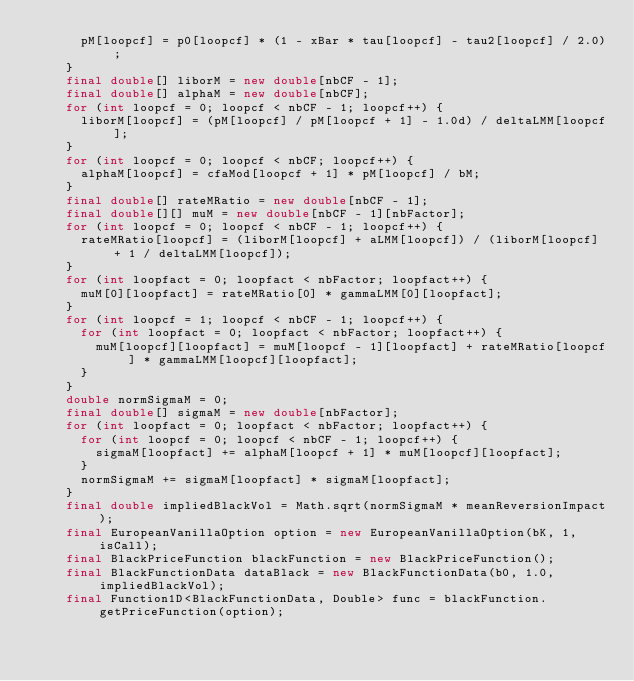<code> <loc_0><loc_0><loc_500><loc_500><_Java_>      pM[loopcf] = p0[loopcf] * (1 - xBar * tau[loopcf] - tau2[loopcf] / 2.0);
    }
    final double[] liborM = new double[nbCF - 1];
    final double[] alphaM = new double[nbCF];
    for (int loopcf = 0; loopcf < nbCF - 1; loopcf++) {
      liborM[loopcf] = (pM[loopcf] / pM[loopcf + 1] - 1.0d) / deltaLMM[loopcf];
    }
    for (int loopcf = 0; loopcf < nbCF; loopcf++) {
      alphaM[loopcf] = cfaMod[loopcf + 1] * pM[loopcf] / bM;
    }
    final double[] rateMRatio = new double[nbCF - 1];
    final double[][] muM = new double[nbCF - 1][nbFactor];
    for (int loopcf = 0; loopcf < nbCF - 1; loopcf++) {
      rateMRatio[loopcf] = (liborM[loopcf] + aLMM[loopcf]) / (liborM[loopcf] + 1 / deltaLMM[loopcf]);
    }
    for (int loopfact = 0; loopfact < nbFactor; loopfact++) {
      muM[0][loopfact] = rateMRatio[0] * gammaLMM[0][loopfact];
    }
    for (int loopcf = 1; loopcf < nbCF - 1; loopcf++) {
      for (int loopfact = 0; loopfact < nbFactor; loopfact++) {
        muM[loopcf][loopfact] = muM[loopcf - 1][loopfact] + rateMRatio[loopcf] * gammaLMM[loopcf][loopfact];
      }
    }
    double normSigmaM = 0;
    final double[] sigmaM = new double[nbFactor];
    for (int loopfact = 0; loopfact < nbFactor; loopfact++) {
      for (int loopcf = 0; loopcf < nbCF - 1; loopcf++) {
        sigmaM[loopfact] += alphaM[loopcf + 1] * muM[loopcf][loopfact];
      }
      normSigmaM += sigmaM[loopfact] * sigmaM[loopfact];
    }
    final double impliedBlackVol = Math.sqrt(normSigmaM * meanReversionImpact);
    final EuropeanVanillaOption option = new EuropeanVanillaOption(bK, 1, isCall);
    final BlackPriceFunction blackFunction = new BlackPriceFunction();
    final BlackFunctionData dataBlack = new BlackFunctionData(b0, 1.0, impliedBlackVol);
    final Function1D<BlackFunctionData, Double> func = blackFunction.getPriceFunction(option);</code> 